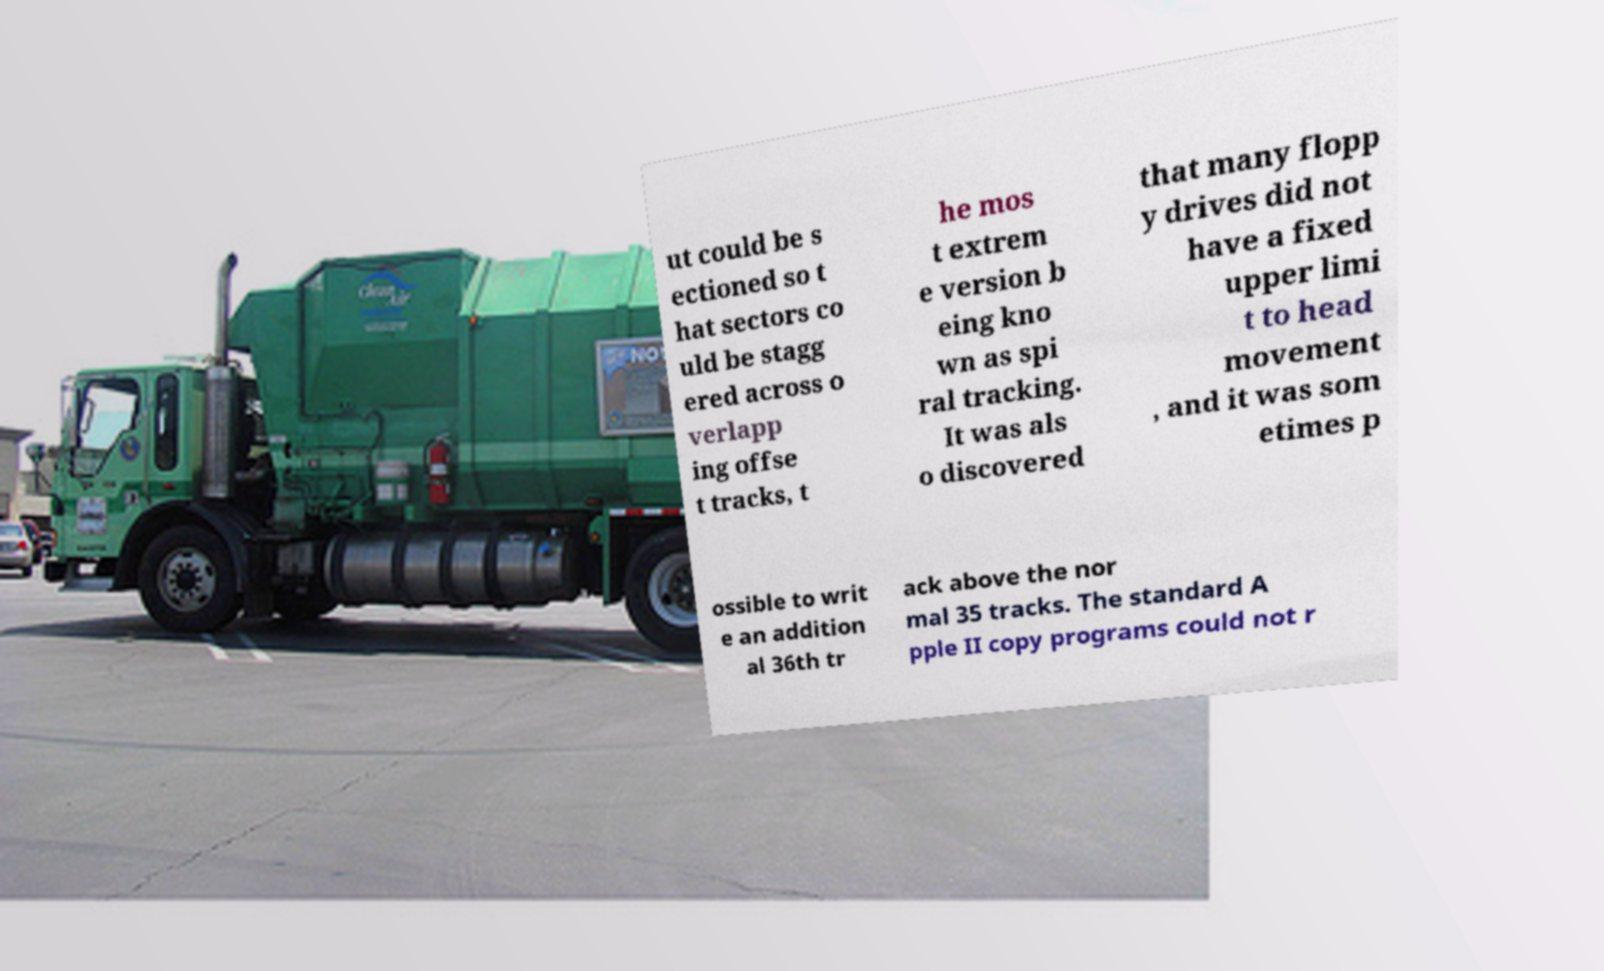I need the written content from this picture converted into text. Can you do that? ut could be s ectioned so t hat sectors co uld be stagg ered across o verlapp ing offse t tracks, t he mos t extrem e version b eing kno wn as spi ral tracking. It was als o discovered that many flopp y drives did not have a fixed upper limi t to head movement , and it was som etimes p ossible to writ e an addition al 36th tr ack above the nor mal 35 tracks. The standard A pple II copy programs could not r 